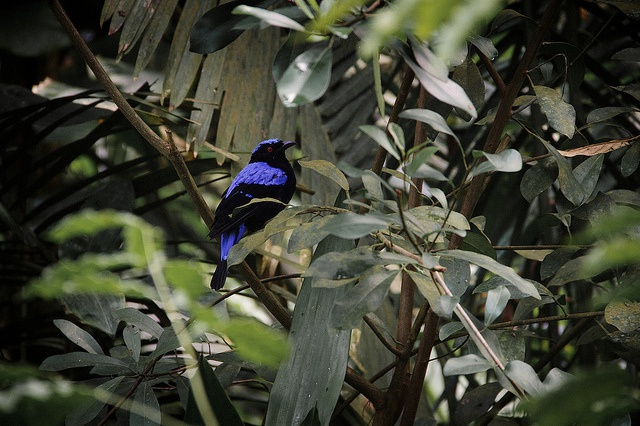Describe the objects in this image and their specific colors. I can see a bird in black, blue, gray, and darkblue tones in this image. 